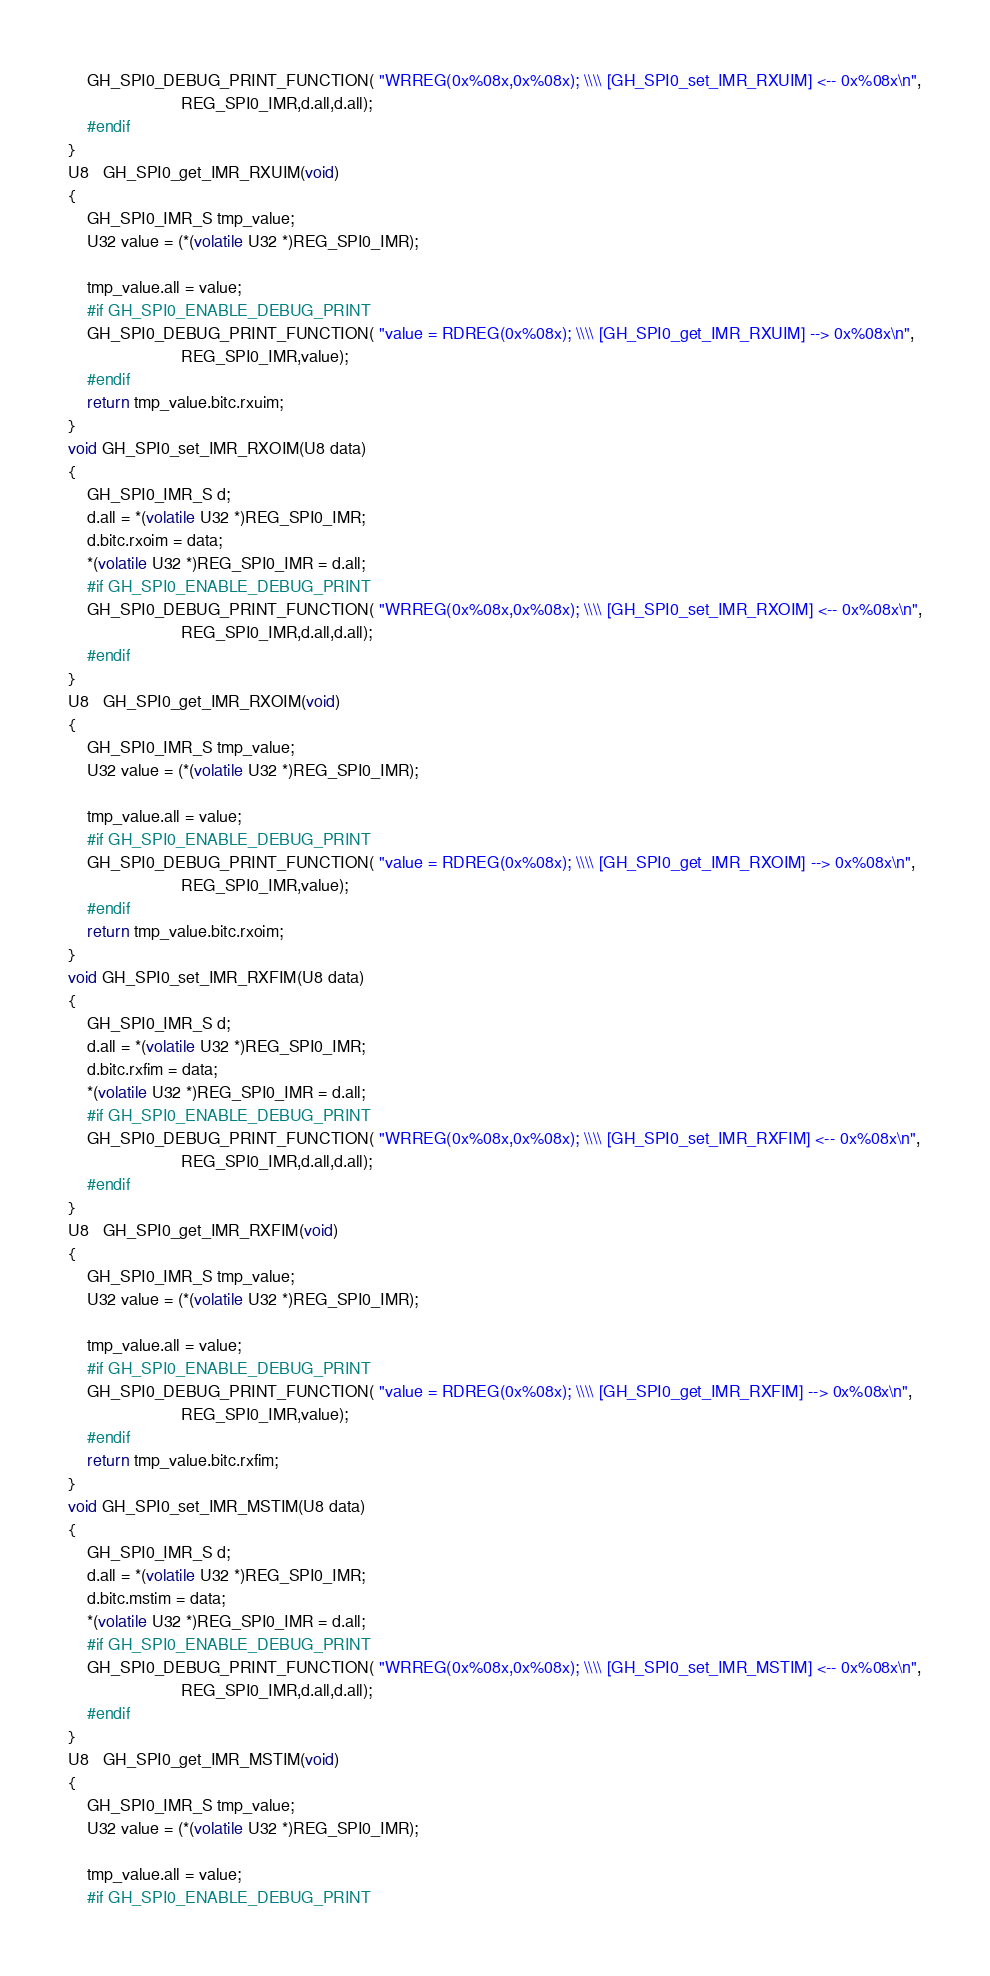<code> <loc_0><loc_0><loc_500><loc_500><_C_>    GH_SPI0_DEBUG_PRINT_FUNCTION( "WRREG(0x%08x,0x%08x); \\\\ [GH_SPI0_set_IMR_RXUIM] <-- 0x%08x\n",
                        REG_SPI0_IMR,d.all,d.all);
    #endif
}
U8   GH_SPI0_get_IMR_RXUIM(void)
{
    GH_SPI0_IMR_S tmp_value;
    U32 value = (*(volatile U32 *)REG_SPI0_IMR);

    tmp_value.all = value;
    #if GH_SPI0_ENABLE_DEBUG_PRINT
    GH_SPI0_DEBUG_PRINT_FUNCTION( "value = RDREG(0x%08x); \\\\ [GH_SPI0_get_IMR_RXUIM] --> 0x%08x\n",
                        REG_SPI0_IMR,value);
    #endif
    return tmp_value.bitc.rxuim;
}
void GH_SPI0_set_IMR_RXOIM(U8 data)
{
    GH_SPI0_IMR_S d;
    d.all = *(volatile U32 *)REG_SPI0_IMR;
    d.bitc.rxoim = data;
    *(volatile U32 *)REG_SPI0_IMR = d.all;
    #if GH_SPI0_ENABLE_DEBUG_PRINT
    GH_SPI0_DEBUG_PRINT_FUNCTION( "WRREG(0x%08x,0x%08x); \\\\ [GH_SPI0_set_IMR_RXOIM] <-- 0x%08x\n",
                        REG_SPI0_IMR,d.all,d.all);
    #endif
}
U8   GH_SPI0_get_IMR_RXOIM(void)
{
    GH_SPI0_IMR_S tmp_value;
    U32 value = (*(volatile U32 *)REG_SPI0_IMR);

    tmp_value.all = value;
    #if GH_SPI0_ENABLE_DEBUG_PRINT
    GH_SPI0_DEBUG_PRINT_FUNCTION( "value = RDREG(0x%08x); \\\\ [GH_SPI0_get_IMR_RXOIM] --> 0x%08x\n",
                        REG_SPI0_IMR,value);
    #endif
    return tmp_value.bitc.rxoim;
}
void GH_SPI0_set_IMR_RXFIM(U8 data)
{
    GH_SPI0_IMR_S d;
    d.all = *(volatile U32 *)REG_SPI0_IMR;
    d.bitc.rxfim = data;
    *(volatile U32 *)REG_SPI0_IMR = d.all;
    #if GH_SPI0_ENABLE_DEBUG_PRINT
    GH_SPI0_DEBUG_PRINT_FUNCTION( "WRREG(0x%08x,0x%08x); \\\\ [GH_SPI0_set_IMR_RXFIM] <-- 0x%08x\n",
                        REG_SPI0_IMR,d.all,d.all);
    #endif
}
U8   GH_SPI0_get_IMR_RXFIM(void)
{
    GH_SPI0_IMR_S tmp_value;
    U32 value = (*(volatile U32 *)REG_SPI0_IMR);

    tmp_value.all = value;
    #if GH_SPI0_ENABLE_DEBUG_PRINT
    GH_SPI0_DEBUG_PRINT_FUNCTION( "value = RDREG(0x%08x); \\\\ [GH_SPI0_get_IMR_RXFIM] --> 0x%08x\n",
                        REG_SPI0_IMR,value);
    #endif
    return tmp_value.bitc.rxfim;
}
void GH_SPI0_set_IMR_MSTIM(U8 data)
{
    GH_SPI0_IMR_S d;
    d.all = *(volatile U32 *)REG_SPI0_IMR;
    d.bitc.mstim = data;
    *(volatile U32 *)REG_SPI0_IMR = d.all;
    #if GH_SPI0_ENABLE_DEBUG_PRINT
    GH_SPI0_DEBUG_PRINT_FUNCTION( "WRREG(0x%08x,0x%08x); \\\\ [GH_SPI0_set_IMR_MSTIM] <-- 0x%08x\n",
                        REG_SPI0_IMR,d.all,d.all);
    #endif
}
U8   GH_SPI0_get_IMR_MSTIM(void)
{
    GH_SPI0_IMR_S tmp_value;
    U32 value = (*(volatile U32 *)REG_SPI0_IMR);

    tmp_value.all = value;
    #if GH_SPI0_ENABLE_DEBUG_PRINT</code> 